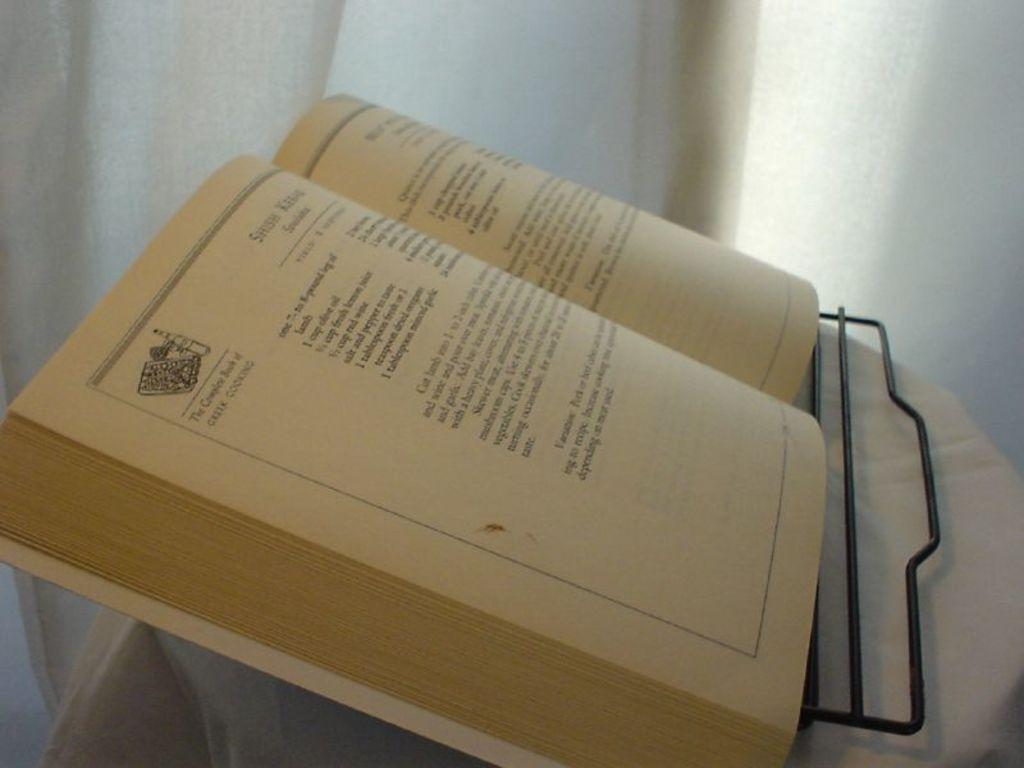<image>
Share a concise interpretation of the image provided. A book lies open and it has the words Greek Cooking written near the corner of a page. 